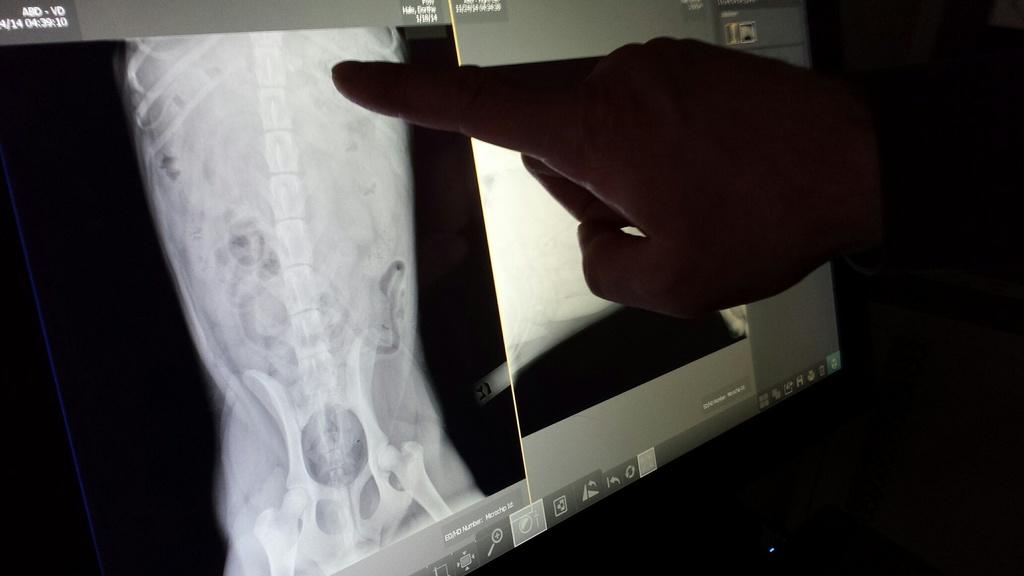What can be seen in the image related to a person's hand? There is a person's hand in the image. What is the hand placed in front of? The hand is placed in front of a monitor. What is displayed on the monitor? The monitor displays an x-ray. How would you describe the overall lighting in the image? The background of the image is dark. What type of watch is the person wearing in the image? There is no watch visible in the image; only the person's hand and a monitor displaying an x-ray are present. 